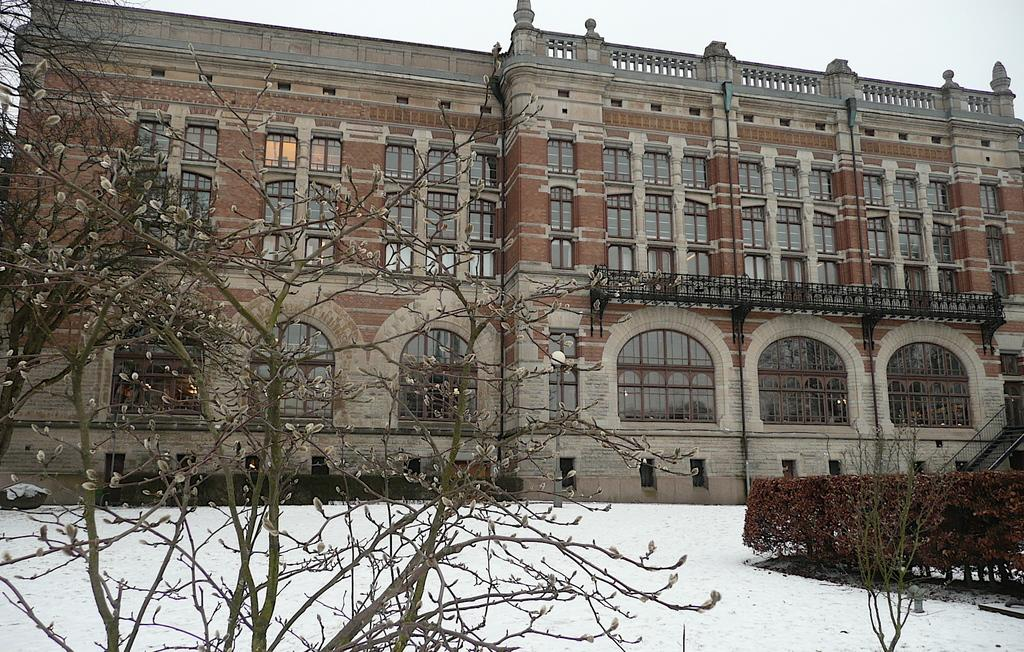What type of vegetation can be seen in the image? There are trees in the image. What is covering the ground in the image? There is snow visible in the image. What type of structure is present in the image? There is a building with windows in the image. What can be seen in the background of the image? The sky is visible in the background of the image. What type of order is being followed by the blade in the image? There is no blade present in the image. What reason might the trees have for being in the image? The trees are not making a conscious decision to be in the image; they are simply part of the natural environment. 